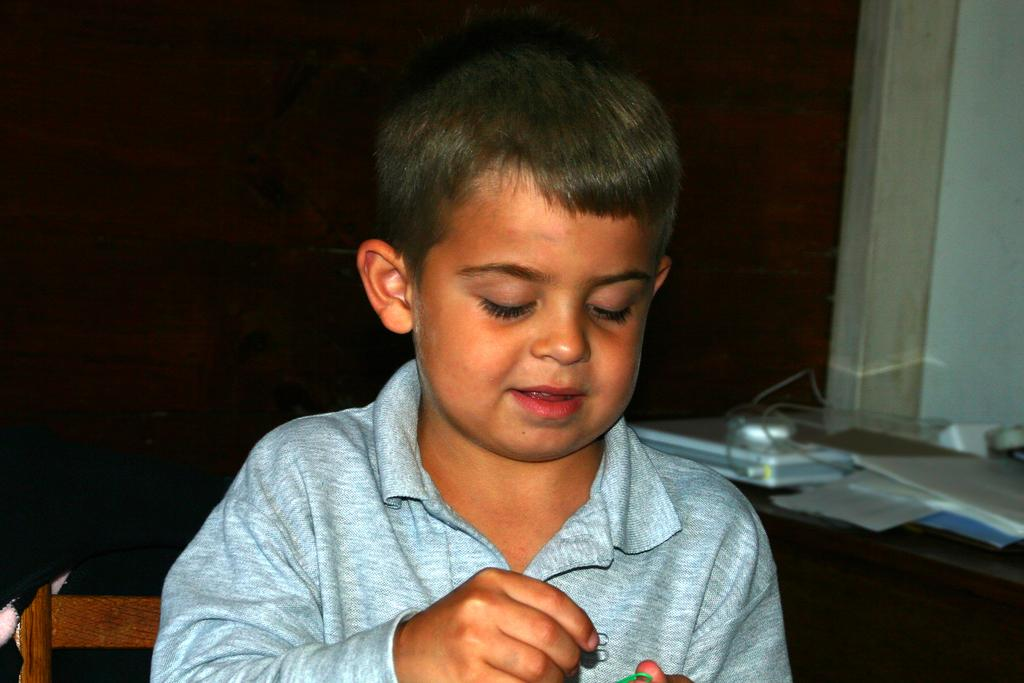What is the boy doing in the image? The boy is sitting on a chair in the image. What can be seen on the right side of the image? There is a table on the right side of the image. What is on the table in the image? The table has a laptop, papers, and a book on it. Are there any other objects on the table? Yes, there are other objects on the table. What is visible in the background of the image? There is a wall in the background of the image. What type of key is used to unlock the vein in the image? There is no key or vein present in the image. 